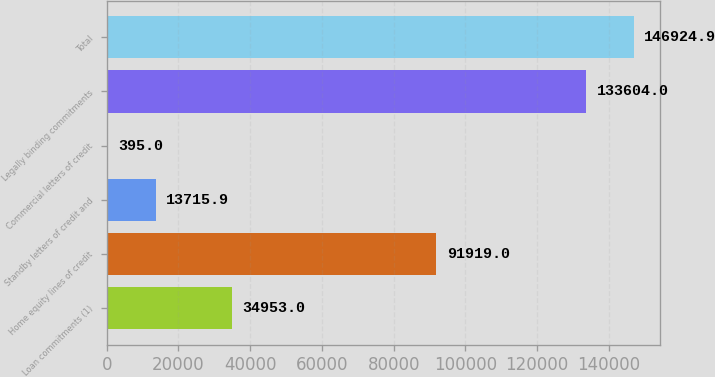Convert chart. <chart><loc_0><loc_0><loc_500><loc_500><bar_chart><fcel>Loan commitments (1)<fcel>Home equity lines of credit<fcel>Standby letters of credit and<fcel>Commercial letters of credit<fcel>Legally binding commitments<fcel>Total<nl><fcel>34953<fcel>91919<fcel>13715.9<fcel>395<fcel>133604<fcel>146925<nl></chart> 